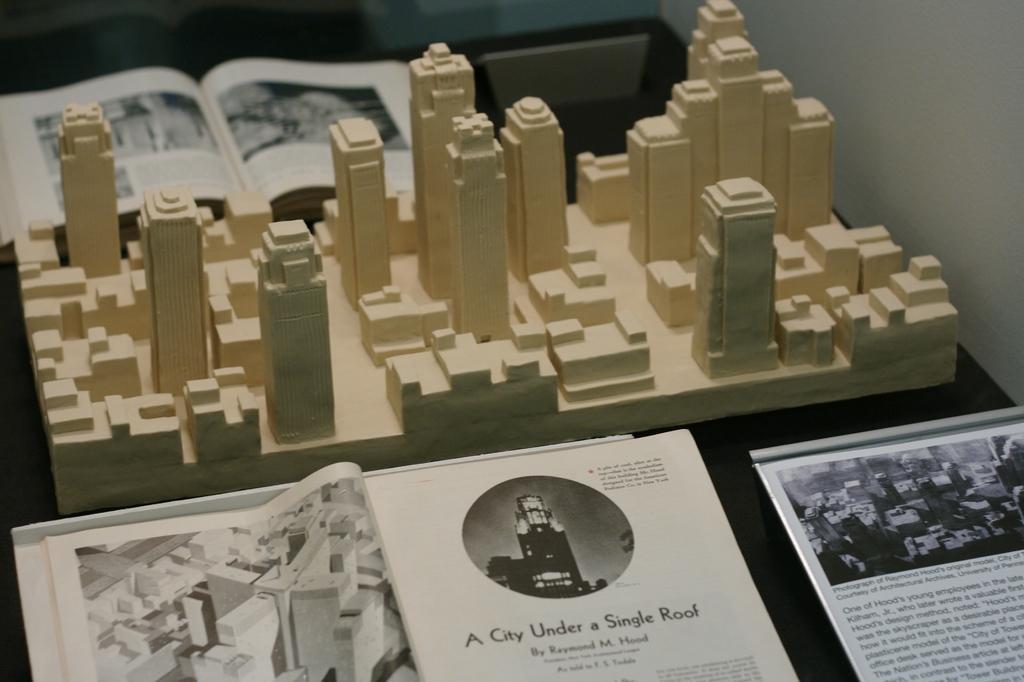Describe this image in one or two sentences. In the picture we can see a module of the buildings on the table and on either side of the module we can see the magazines with some images and information. 